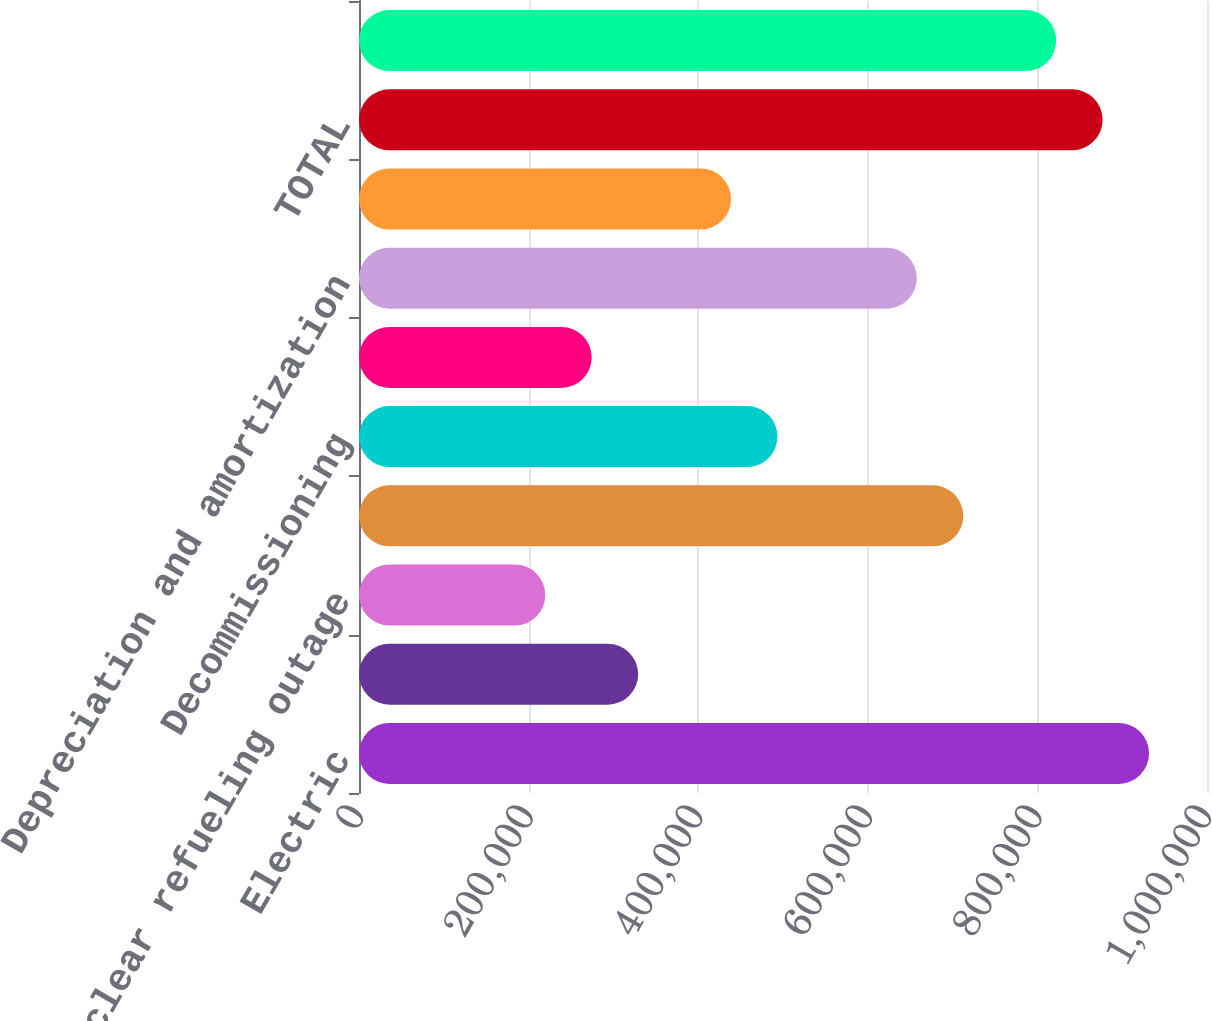Convert chart to OTSL. <chart><loc_0><loc_0><loc_500><loc_500><bar_chart><fcel>Electric<fcel>Fuel fuel-related expenses and<fcel>Nuclear refueling outage<fcel>Other operation and<fcel>Decommissioning<fcel>Taxes other than income taxes<fcel>Depreciation and amortization<fcel>Other regulatory credits - net<fcel>TOTAL<fcel>OPERATING INCOME<nl><fcel>931706<fcel>329197<fcel>219650<fcel>712612<fcel>493518<fcel>274424<fcel>657838<fcel>438744<fcel>876932<fcel>822158<nl></chart> 